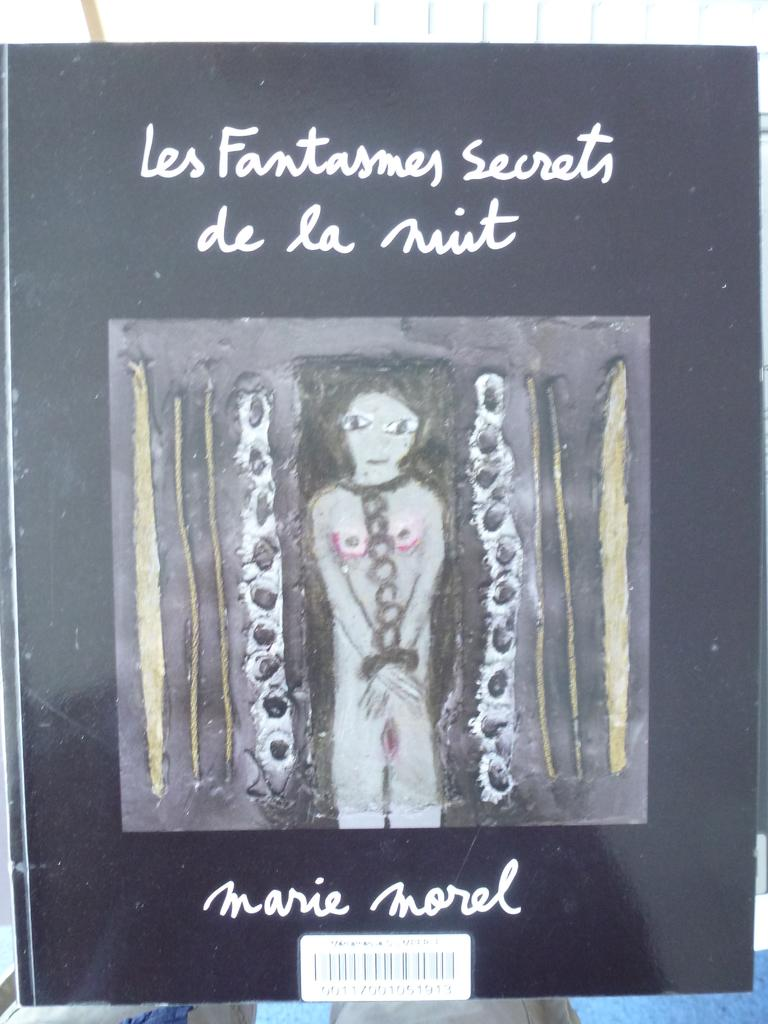What is present on the poster in the image? The poster contains images and text. Can you describe the images on the poster? The provided facts do not specify the images on the poster, so we cannot describe them. What is the purpose of the bar code at the bottom of the poster? The bar code at the bottom of the poster is likely used for tracking or identification purposes. How many balloons are floating above the poster in the image? There are no balloons present in the image. What message does the poster convey about love? The provided facts do not mention any message about love, as the focus is on the poster's content and features. 